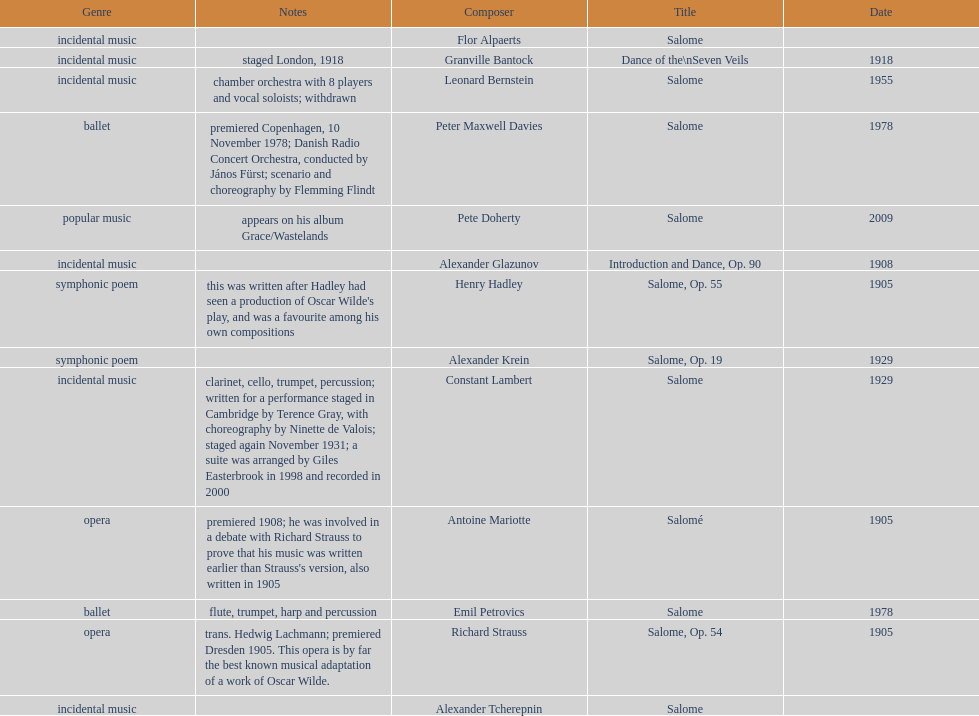Which composer is listed below pete doherty? Alexander Glazunov. 